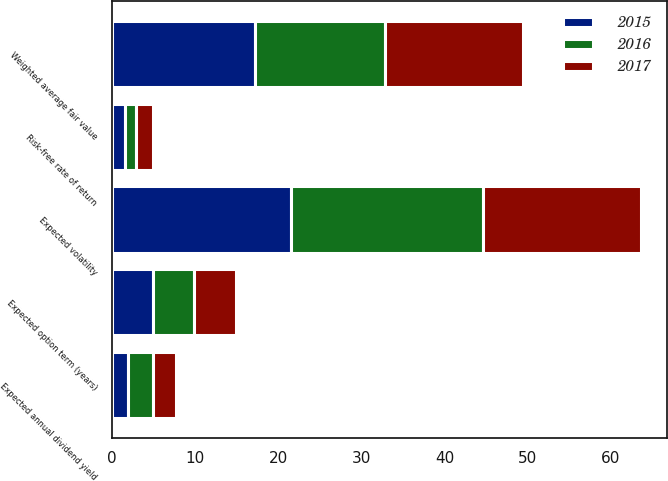<chart> <loc_0><loc_0><loc_500><loc_500><stacked_bar_chart><ecel><fcel>Weighted average fair value<fcel>Expected annual dividend yield<fcel>Expected volatility<fcel>Risk-free rate of return<fcel>Expected option term (years)<nl><fcel>2017<fcel>16.68<fcel>2.81<fcel>18.96<fcel>2.02<fcel>5.04<nl><fcel>2016<fcel>15.59<fcel>2.92<fcel>23.07<fcel>1.29<fcel>4.97<nl><fcel>2015<fcel>17.21<fcel>1.98<fcel>21.55<fcel>1.61<fcel>4.96<nl></chart> 